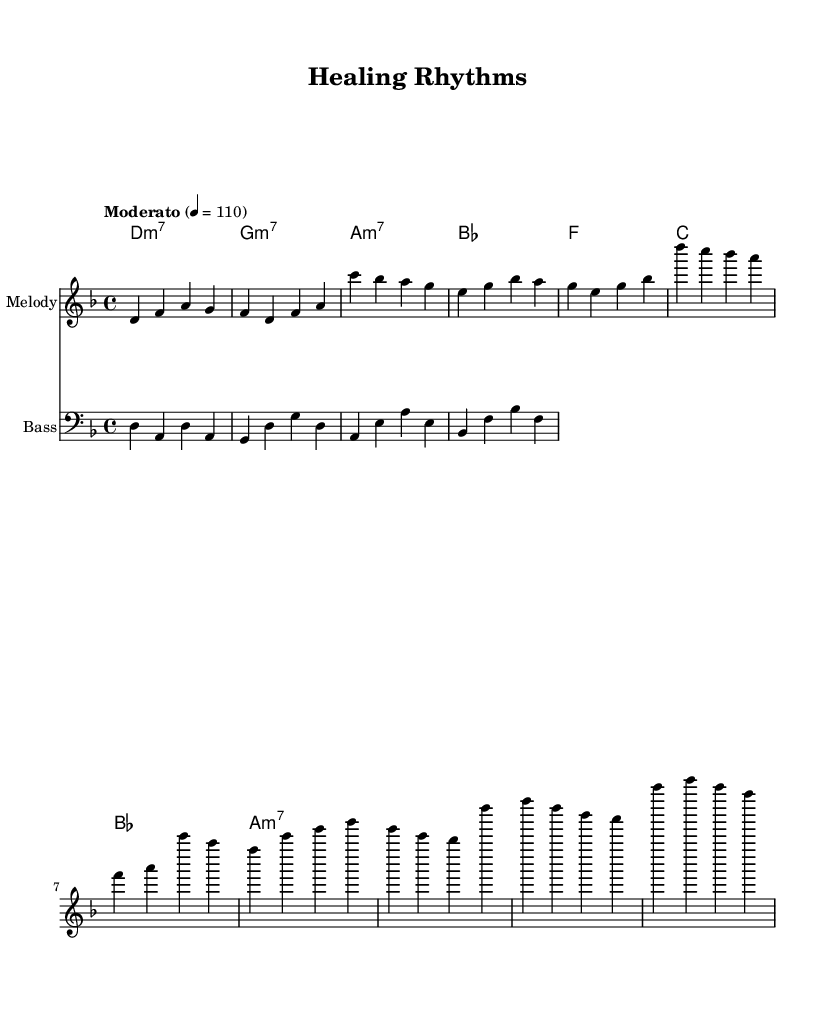What is the key signature of this music? The key signature shown in the global section indicates 'd minor', which is represented by one flat (B flat).
Answer: D minor What is the time signature of this music? The time signature indicated in the global section is '4/4', meaning there are four beats in each measure.
Answer: 4/4 What is the tempo marking for the piece? The tempo is marked as "Moderato" with a metronome marking of 110 beats per minute, suggesting a medium pace for the music.
Answer: Moderato 110 How many measures are there in the verse? Counting the measures in the melody section, there are eight measures in the verse before transitioning to the chorus.
Answer: Eight Which chord appears in the chorus? The harmonies section shows the chords used in the chorus, with 'F' appearing as the first chord in the chorus.
Answer: F What lyrical theme is promoted in this song? Analyzing the lyrics provided, the theme revolves around natural remedies and holistic wellness, emphasizing the healing properties of nature.
Answer: Healing and wellness What musical genre does this piece represent? Given the combination of Latin rhythms and jazz harmonies, along with the lyrical focus, it fits into the category of Latin jazz fusion.
Answer: Latin jazz fusion 